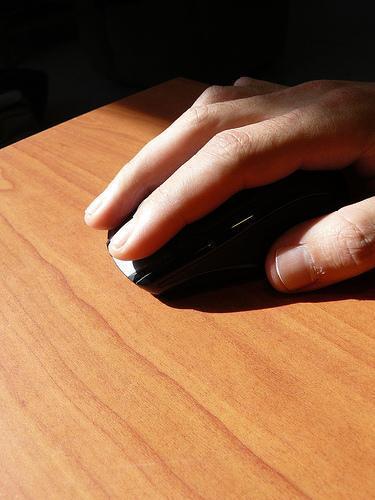How many fingers are there?
Give a very brief answer. 5. 